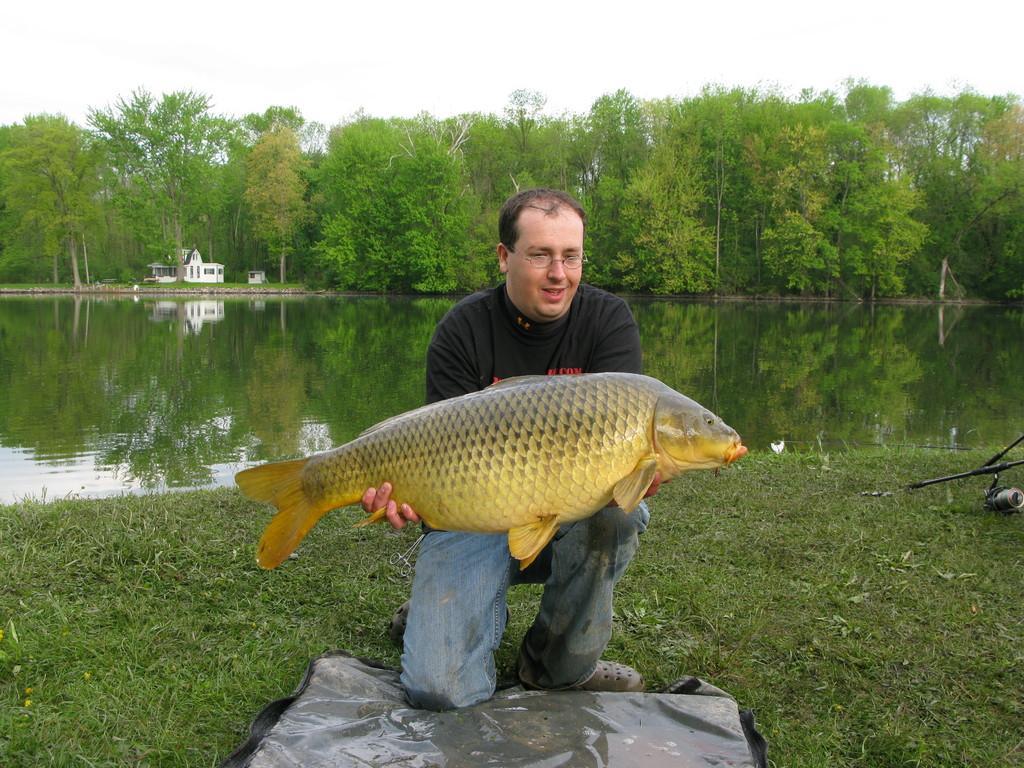How would you summarize this image in a sentence or two? In the center of the image we can see a man is sitting on his knees and holding a fish. In the background of the image we can see the trees, water, house. At the bottom of the image we can see the grass and plastic cover. At the top of the image we can see the sky. 